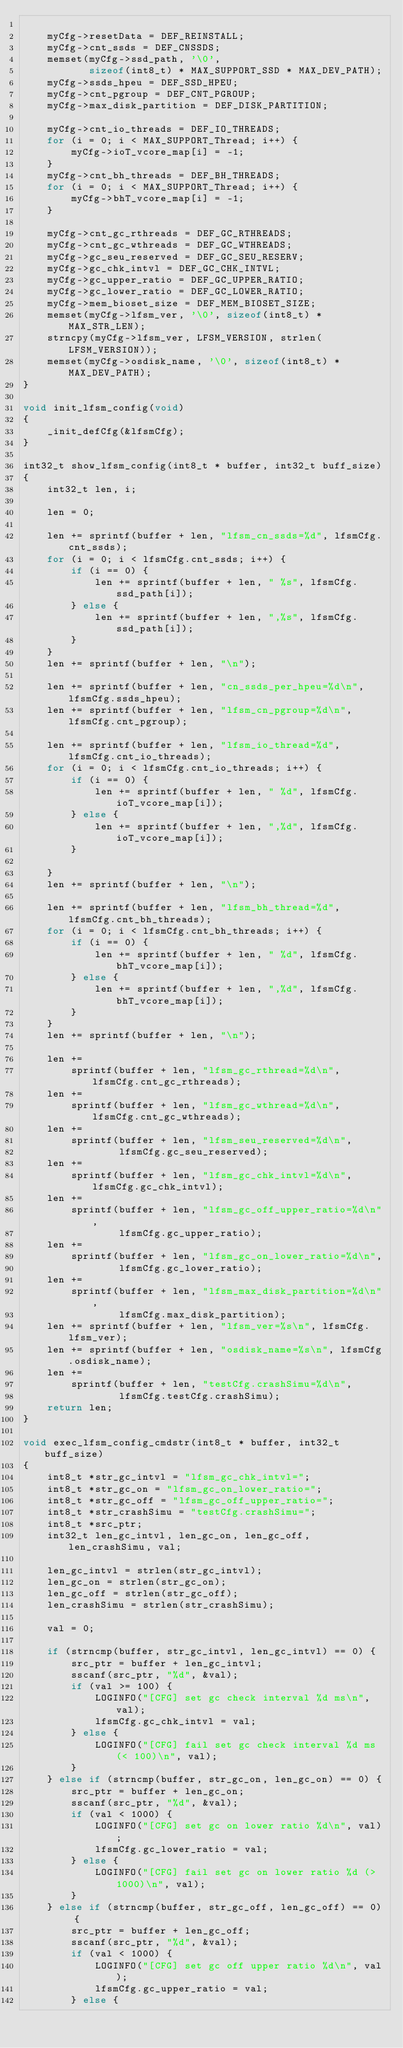<code> <loc_0><loc_0><loc_500><loc_500><_C_>
    myCfg->resetData = DEF_REINSTALL;
    myCfg->cnt_ssds = DEF_CNSSDS;
    memset(myCfg->ssd_path, '\0',
           sizeof(int8_t) * MAX_SUPPORT_SSD * MAX_DEV_PATH);
    myCfg->ssds_hpeu = DEF_SSD_HPEU;
    myCfg->cnt_pgroup = DEF_CNT_PGROUP;
    myCfg->max_disk_partition = DEF_DISK_PARTITION;

    myCfg->cnt_io_threads = DEF_IO_THREADS;
    for (i = 0; i < MAX_SUPPORT_Thread; i++) {
        myCfg->ioT_vcore_map[i] = -1;
    }
    myCfg->cnt_bh_threads = DEF_BH_THREADS;
    for (i = 0; i < MAX_SUPPORT_Thread; i++) {
        myCfg->bhT_vcore_map[i] = -1;
    }

    myCfg->cnt_gc_rthreads = DEF_GC_RTHREADS;
    myCfg->cnt_gc_wthreads = DEF_GC_WTHREADS;
    myCfg->gc_seu_reserved = DEF_GC_SEU_RESERV;
    myCfg->gc_chk_intvl = DEF_GC_CHK_INTVL;
    myCfg->gc_upper_ratio = DEF_GC_UPPER_RATIO;
    myCfg->gc_lower_ratio = DEF_GC_LOWER_RATIO;
    myCfg->mem_bioset_size = DEF_MEM_BIOSET_SIZE;
    memset(myCfg->lfsm_ver, '\0', sizeof(int8_t) * MAX_STR_LEN);
    strncpy(myCfg->lfsm_ver, LFSM_VERSION, strlen(LFSM_VERSION));
    memset(myCfg->osdisk_name, '\0', sizeof(int8_t) * MAX_DEV_PATH);
}

void init_lfsm_config(void)
{
    _init_defCfg(&lfsmCfg);
}

int32_t show_lfsm_config(int8_t * buffer, int32_t buff_size)
{
    int32_t len, i;

    len = 0;

    len += sprintf(buffer + len, "lfsm_cn_ssds=%d", lfsmCfg.cnt_ssds);
    for (i = 0; i < lfsmCfg.cnt_ssds; i++) {
        if (i == 0) {
            len += sprintf(buffer + len, " %s", lfsmCfg.ssd_path[i]);
        } else {
            len += sprintf(buffer + len, ",%s", lfsmCfg.ssd_path[i]);
        }
    }
    len += sprintf(buffer + len, "\n");

    len += sprintf(buffer + len, "cn_ssds_per_hpeu=%d\n", lfsmCfg.ssds_hpeu);
    len += sprintf(buffer + len, "lfsm_cn_pgroup=%d\n", lfsmCfg.cnt_pgroup);

    len += sprintf(buffer + len, "lfsm_io_thread=%d", lfsmCfg.cnt_io_threads);
    for (i = 0; i < lfsmCfg.cnt_io_threads; i++) {
        if (i == 0) {
            len += sprintf(buffer + len, " %d", lfsmCfg.ioT_vcore_map[i]);
        } else {
            len += sprintf(buffer + len, ",%d", lfsmCfg.ioT_vcore_map[i]);
        }

    }
    len += sprintf(buffer + len, "\n");

    len += sprintf(buffer + len, "lfsm_bh_thread=%d", lfsmCfg.cnt_bh_threads);
    for (i = 0; i < lfsmCfg.cnt_bh_threads; i++) {
        if (i == 0) {
            len += sprintf(buffer + len, " %d", lfsmCfg.bhT_vcore_map[i]);
        } else {
            len += sprintf(buffer + len, ",%d", lfsmCfg.bhT_vcore_map[i]);
        }
    }
    len += sprintf(buffer + len, "\n");

    len +=
        sprintf(buffer + len, "lfsm_gc_rthread=%d\n", lfsmCfg.cnt_gc_rthreads);
    len +=
        sprintf(buffer + len, "lfsm_gc_wthread=%d\n", lfsmCfg.cnt_gc_wthreads);
    len +=
        sprintf(buffer + len, "lfsm_seu_reserved=%d\n",
                lfsmCfg.gc_seu_reserved);
    len +=
        sprintf(buffer + len, "lfsm_gc_chk_intvl=%d\n", lfsmCfg.gc_chk_intvl);
    len +=
        sprintf(buffer + len, "lfsm_gc_off_upper_ratio=%d\n",
                lfsmCfg.gc_upper_ratio);
    len +=
        sprintf(buffer + len, "lfsm_gc_on_lower_ratio=%d\n",
                lfsmCfg.gc_lower_ratio);
    len +=
        sprintf(buffer + len, "lfsm_max_disk_partition=%d\n",
                lfsmCfg.max_disk_partition);
    len += sprintf(buffer + len, "lfsm_ver=%s\n", lfsmCfg.lfsm_ver);
    len += sprintf(buffer + len, "osdisk_name=%s\n", lfsmCfg.osdisk_name);
    len +=
        sprintf(buffer + len, "testCfg.crashSimu=%d\n",
                lfsmCfg.testCfg.crashSimu);
    return len;
}

void exec_lfsm_config_cmdstr(int8_t * buffer, int32_t buff_size)
{
    int8_t *str_gc_intvl = "lfsm_gc_chk_intvl=";
    int8_t *str_gc_on = "lfsm_gc_on_lower_ratio=";
    int8_t *str_gc_off = "lfsm_gc_off_upper_ratio=";
    int8_t *str_crashSimu = "testCfg.crashSimu=";
    int8_t *src_ptr;
    int32_t len_gc_intvl, len_gc_on, len_gc_off, len_crashSimu, val;

    len_gc_intvl = strlen(str_gc_intvl);
    len_gc_on = strlen(str_gc_on);
    len_gc_off = strlen(str_gc_off);
    len_crashSimu = strlen(str_crashSimu);

    val = 0;

    if (strncmp(buffer, str_gc_intvl, len_gc_intvl) == 0) {
        src_ptr = buffer + len_gc_intvl;
        sscanf(src_ptr, "%d", &val);
        if (val >= 100) {
            LOGINFO("[CFG] set gc check interval %d ms\n", val);
            lfsmCfg.gc_chk_intvl = val;
        } else {
            LOGINFO("[CFG] fail set gc check interval %d ms (< 100)\n", val);
        }
    } else if (strncmp(buffer, str_gc_on, len_gc_on) == 0) {
        src_ptr = buffer + len_gc_on;
        sscanf(src_ptr, "%d", &val);
        if (val < 1000) {
            LOGINFO("[CFG] set gc on lower ratio %d\n", val);
            lfsmCfg.gc_lower_ratio = val;
        } else {
            LOGINFO("[CFG] fail set gc on lower ratio %d (> 1000)\n", val);
        }
    } else if (strncmp(buffer, str_gc_off, len_gc_off) == 0) {
        src_ptr = buffer + len_gc_off;
        sscanf(src_ptr, "%d", &val);
        if (val < 1000) {
            LOGINFO("[CFG] set gc off upper ratio %d\n", val);
            lfsmCfg.gc_upper_ratio = val;
        } else {</code> 